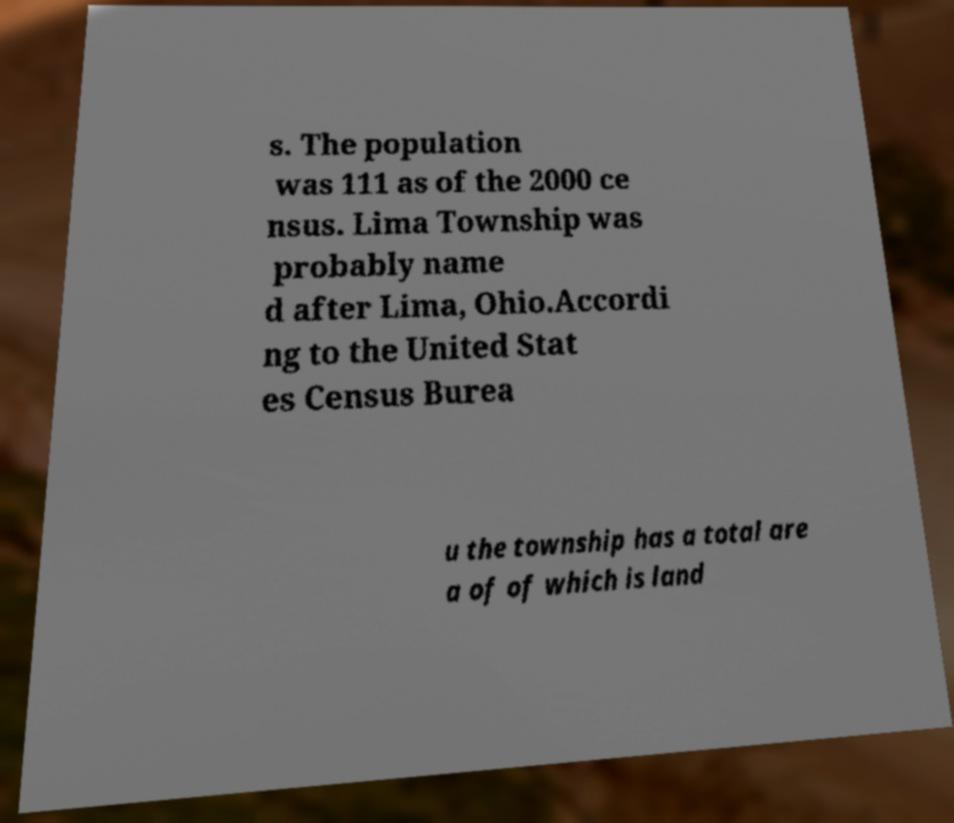Can you read and provide the text displayed in the image?This photo seems to have some interesting text. Can you extract and type it out for me? s. The population was 111 as of the 2000 ce nsus. Lima Township was probably name d after Lima, Ohio.Accordi ng to the United Stat es Census Burea u the township has a total are a of of which is land 